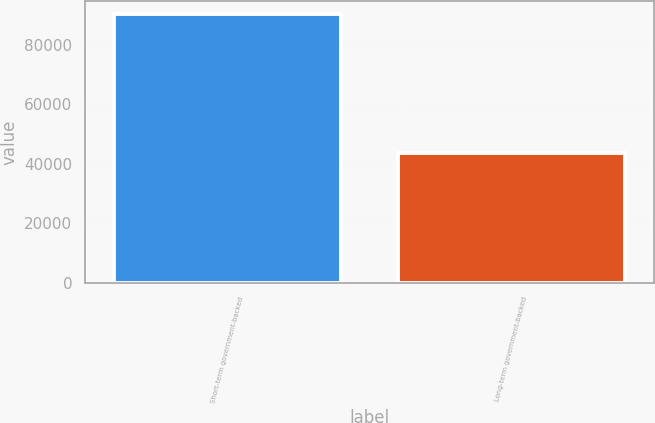Convert chart. <chart><loc_0><loc_0><loc_500><loc_500><bar_chart><fcel>Short-term government-backed<fcel>Long-term government-backed<nl><fcel>90113<fcel>43471<nl></chart> 